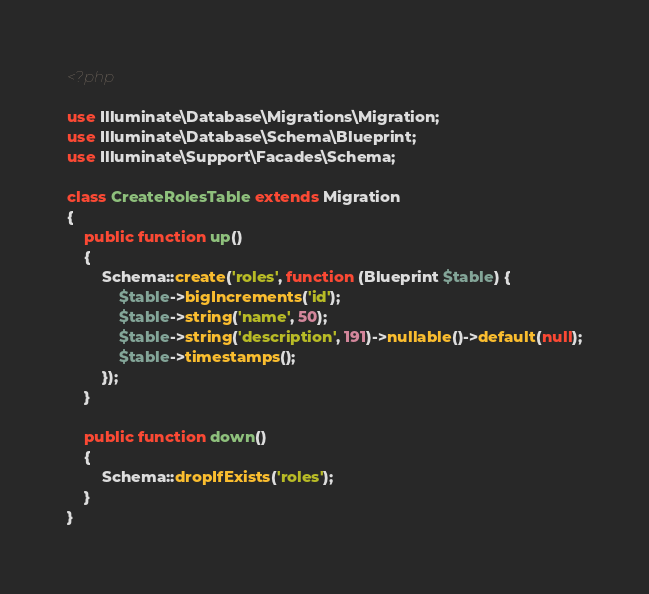Convert code to text. <code><loc_0><loc_0><loc_500><loc_500><_PHP_><?php

use Illuminate\Database\Migrations\Migration;
use Illuminate\Database\Schema\Blueprint;
use Illuminate\Support\Facades\Schema;

class CreateRolesTable extends Migration
{
    public function up()
    {
        Schema::create('roles', function (Blueprint $table) {
            $table->bigIncrements('id');
            $table->string('name', 50);
            $table->string('description', 191)->nullable()->default(null);
            $table->timestamps();
        });
    }

    public function down()
    {
        Schema::dropIfExists('roles');
    }
}
</code> 